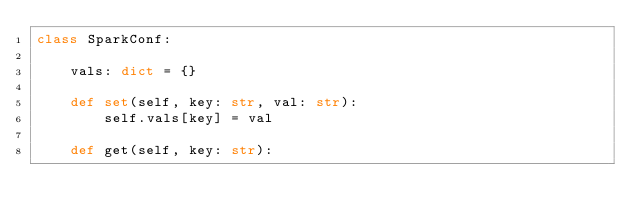Convert code to text. <code><loc_0><loc_0><loc_500><loc_500><_Python_>class SparkConf:

    vals: dict = {}

    def set(self, key: str, val: str):
        self.vals[key] = val

    def get(self, key: str):</code> 